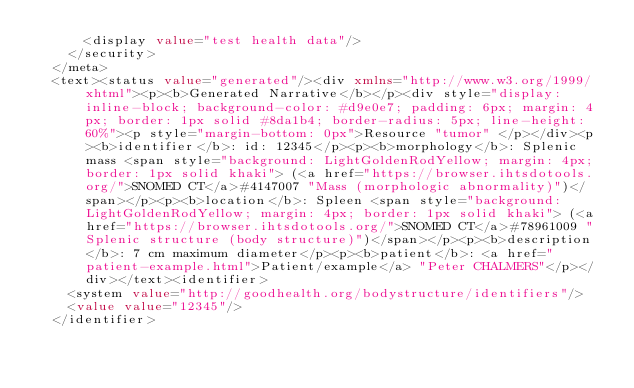<code> <loc_0><loc_0><loc_500><loc_500><_XML_>      <display value="test health data"/>
    </security>
  </meta>
  <text><status value="generated"/><div xmlns="http://www.w3.org/1999/xhtml"><p><b>Generated Narrative</b></p><div style="display: inline-block; background-color: #d9e0e7; padding: 6px; margin: 4px; border: 1px solid #8da1b4; border-radius: 5px; line-height: 60%"><p style="margin-bottom: 0px">Resource "tumor" </p></div><p><b>identifier</b>: id: 12345</p><p><b>morphology</b>: Splenic mass <span style="background: LightGoldenRodYellow; margin: 4px; border: 1px solid khaki"> (<a href="https://browser.ihtsdotools.org/">SNOMED CT</a>#4147007 "Mass (morphologic abnormality)")</span></p><p><b>location</b>: Spleen <span style="background: LightGoldenRodYellow; margin: 4px; border: 1px solid khaki"> (<a href="https://browser.ihtsdotools.org/">SNOMED CT</a>#78961009 "Splenic structure (body structure)")</span></p><p><b>description</b>: 7 cm maximum diameter</p><p><b>patient</b>: <a href="patient-example.html">Patient/example</a> "Peter CHALMERS"</p></div></text><identifier>
		<system value="http://goodhealth.org/bodystructure/identifiers"/>
		<value value="12345"/>
	</identifier></code> 